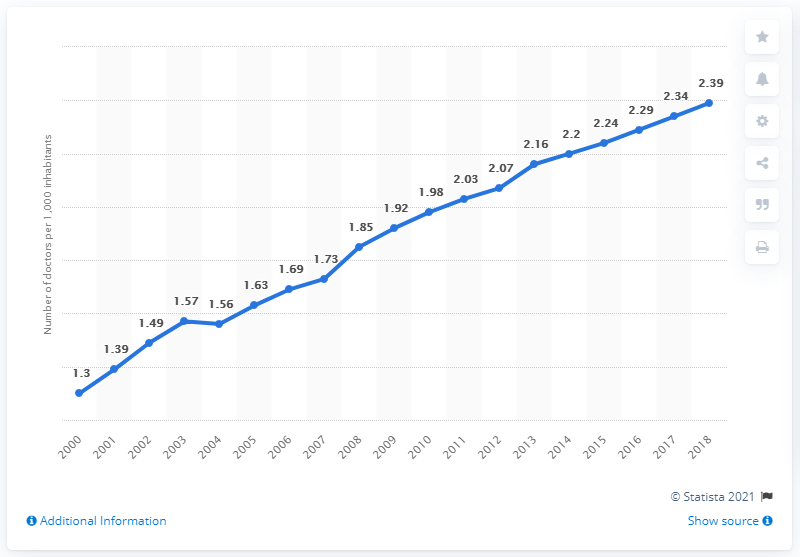List a handful of essential elements in this visual. In 2004, the ratio of doctors for every 1,000 Koreans dropped. In 2018, there were approximately 2.39 doctors for every 1,000 Koreans in South Korea. 